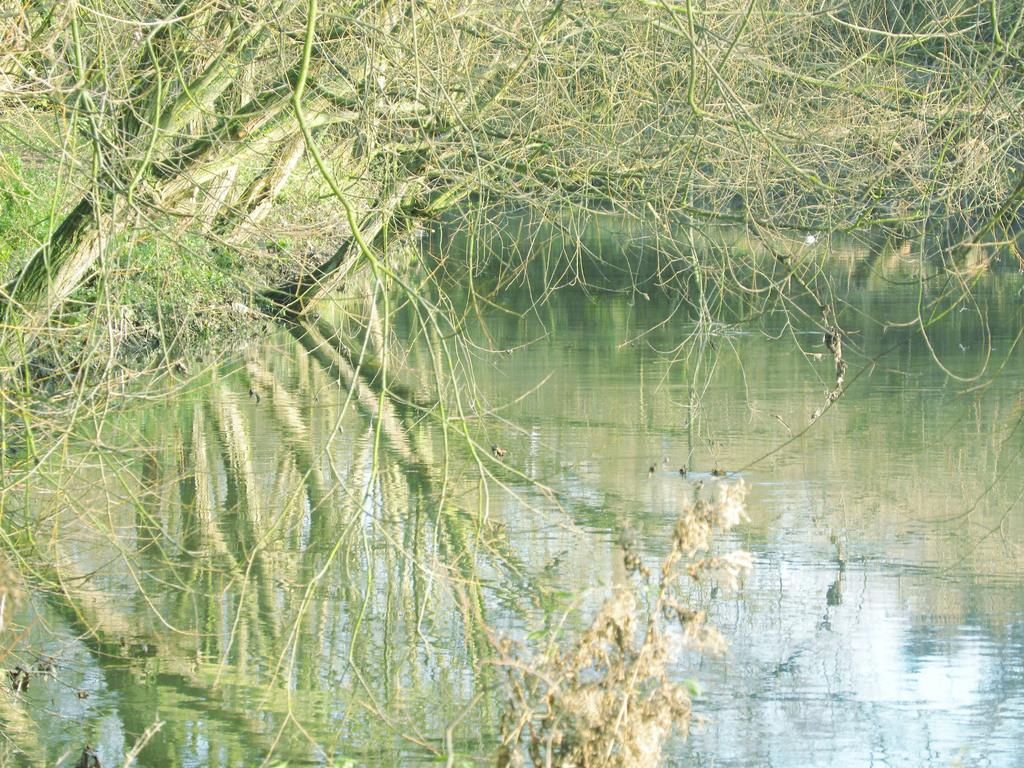What body of water is visible in the image? There is a lake in the image. What type of vegetation surrounds the lake? There are many trees around the lake in the image. Where is the hose connected to the sink in the image? There is no hose or sink present in the image; it only features a lake and trees. 